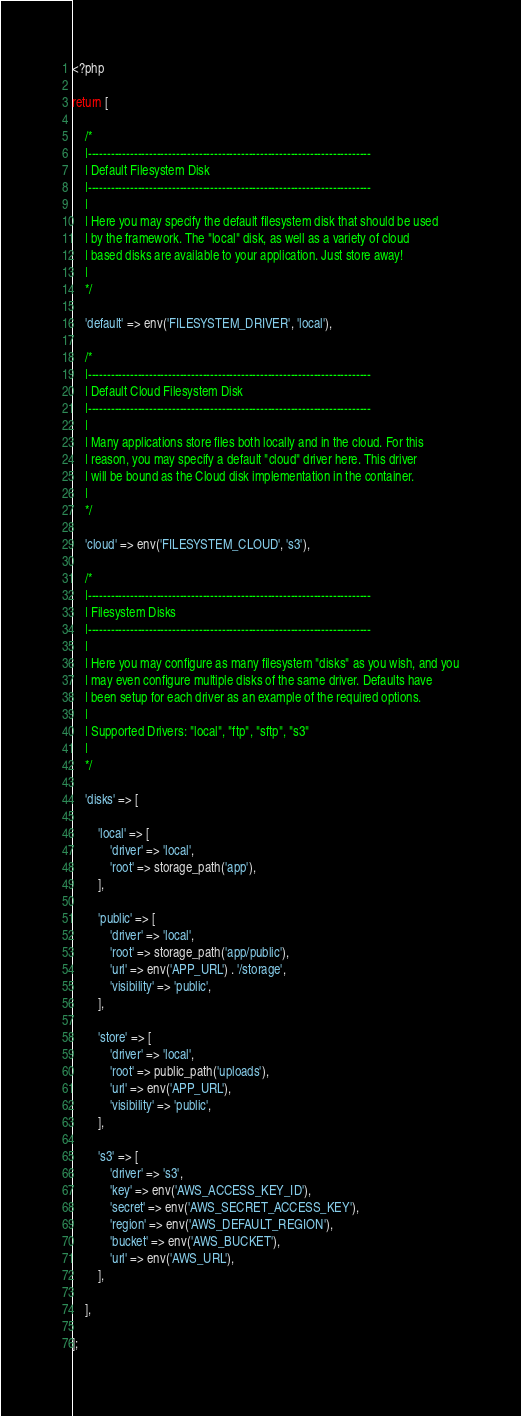<code> <loc_0><loc_0><loc_500><loc_500><_PHP_><?php

return [

    /*
    |--------------------------------------------------------------------------
    | Default Filesystem Disk
    |--------------------------------------------------------------------------
    |
    | Here you may specify the default filesystem disk that should be used
    | by the framework. The "local" disk, as well as a variety of cloud
    | based disks are available to your application. Just store away!
    |
    */

    'default' => env('FILESYSTEM_DRIVER', 'local'),

    /*
    |--------------------------------------------------------------------------
    | Default Cloud Filesystem Disk
    |--------------------------------------------------------------------------
    |
    | Many applications store files both locally and in the cloud. For this
    | reason, you may specify a default "cloud" driver here. This driver
    | will be bound as the Cloud disk implementation in the container.
    |
    */

    'cloud' => env('FILESYSTEM_CLOUD', 's3'),

    /*
    |--------------------------------------------------------------------------
    | Filesystem Disks
    |--------------------------------------------------------------------------
    |
    | Here you may configure as many filesystem "disks" as you wish, and you
    | may even configure multiple disks of the same driver. Defaults have
    | been setup for each driver as an example of the required options.
    |
    | Supported Drivers: "local", "ftp", "sftp", "s3"
    |
    */

    'disks' => [

        'local' => [
            'driver' => 'local',
            'root' => storage_path('app'),
        ],

        'public' => [
            'driver' => 'local',
            'root' => storage_path('app/public'),
            'url' => env('APP_URL') . '/storage',
            'visibility' => 'public',
        ],

        'store' => [
            'driver' => 'local',
            'root' => public_path('uploads'),
            'url' => env('APP_URL'),
            'visibility' => 'public',
        ],

        's3' => [
            'driver' => 's3',
            'key' => env('AWS_ACCESS_KEY_ID'),
            'secret' => env('AWS_SECRET_ACCESS_KEY'),
            'region' => env('AWS_DEFAULT_REGION'),
            'bucket' => env('AWS_BUCKET'),
            'url' => env('AWS_URL'),
        ],

    ],

];
</code> 